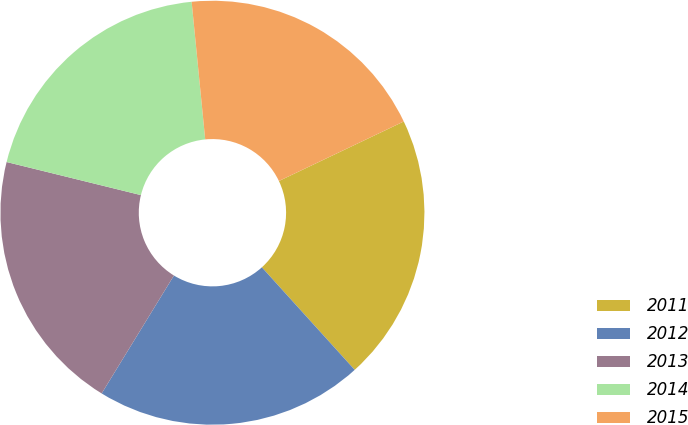<chart> <loc_0><loc_0><loc_500><loc_500><pie_chart><fcel>2011<fcel>2012<fcel>2013<fcel>2014<fcel>2015<nl><fcel>20.37%<fcel>20.46%<fcel>20.09%<fcel>19.59%<fcel>19.48%<nl></chart> 